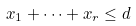<formula> <loc_0><loc_0><loc_500><loc_500>x _ { 1 } + \dots + x _ { r } \leq d</formula> 